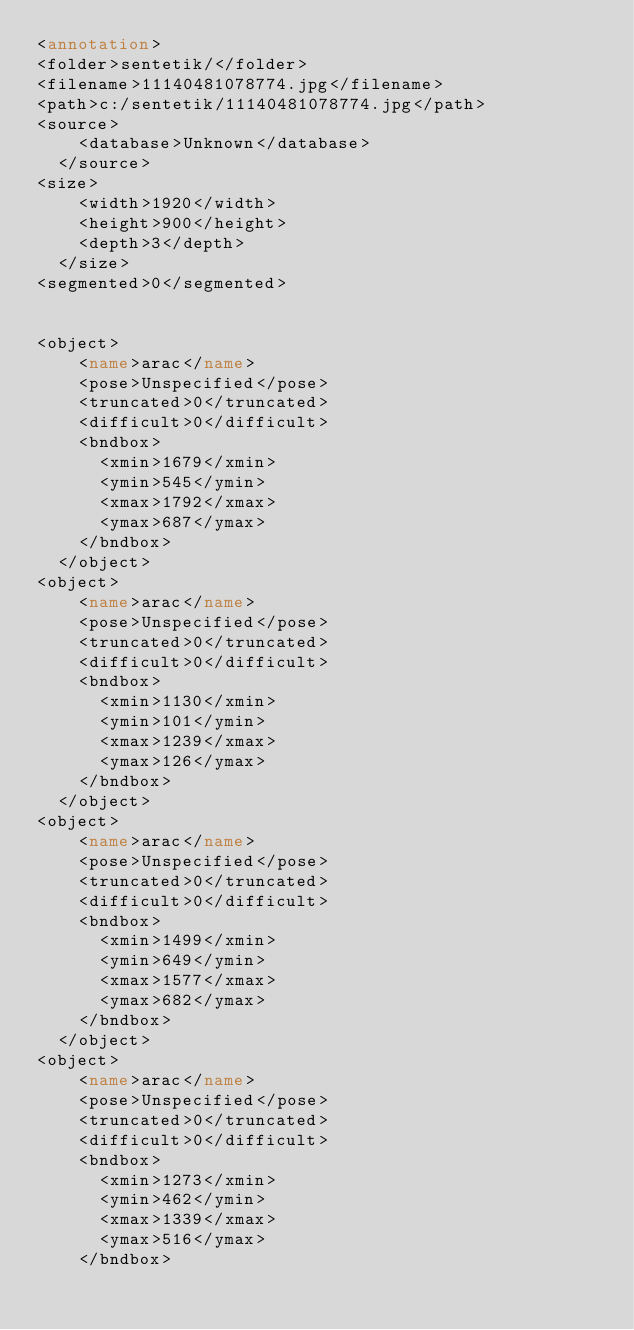<code> <loc_0><loc_0><loc_500><loc_500><_XML_><annotation>
<folder>sentetik/</folder>
<filename>11140481078774.jpg</filename>
<path>c:/sentetik/11140481078774.jpg</path>
<source>
		<database>Unknown</database>
	</source>
<size>
		<width>1920</width>
		<height>900</height>
		<depth>3</depth>
	</size>
<segmented>0</segmented>


<object>
		<name>arac</name>
		<pose>Unspecified</pose>
		<truncated>0</truncated>
		<difficult>0</difficult>
		<bndbox>
			<xmin>1679</xmin>
			<ymin>545</ymin>
			<xmax>1792</xmax>
			<ymax>687</ymax>
		</bndbox>
	</object>
<object>
		<name>arac</name>
		<pose>Unspecified</pose>
		<truncated>0</truncated>
		<difficult>0</difficult>
		<bndbox>
			<xmin>1130</xmin>
			<ymin>101</ymin>
			<xmax>1239</xmax>
			<ymax>126</ymax>
		</bndbox>
	</object>
<object>
		<name>arac</name>
		<pose>Unspecified</pose>
		<truncated>0</truncated>
		<difficult>0</difficult>
		<bndbox>
			<xmin>1499</xmin>
			<ymin>649</ymin>
			<xmax>1577</xmax>
			<ymax>682</ymax>
		</bndbox>
	</object>
<object>
		<name>arac</name>
		<pose>Unspecified</pose>
		<truncated>0</truncated>
		<difficult>0</difficult>
		<bndbox>
			<xmin>1273</xmin>
			<ymin>462</ymin>
			<xmax>1339</xmax>
			<ymax>516</ymax>
		</bndbox></code> 